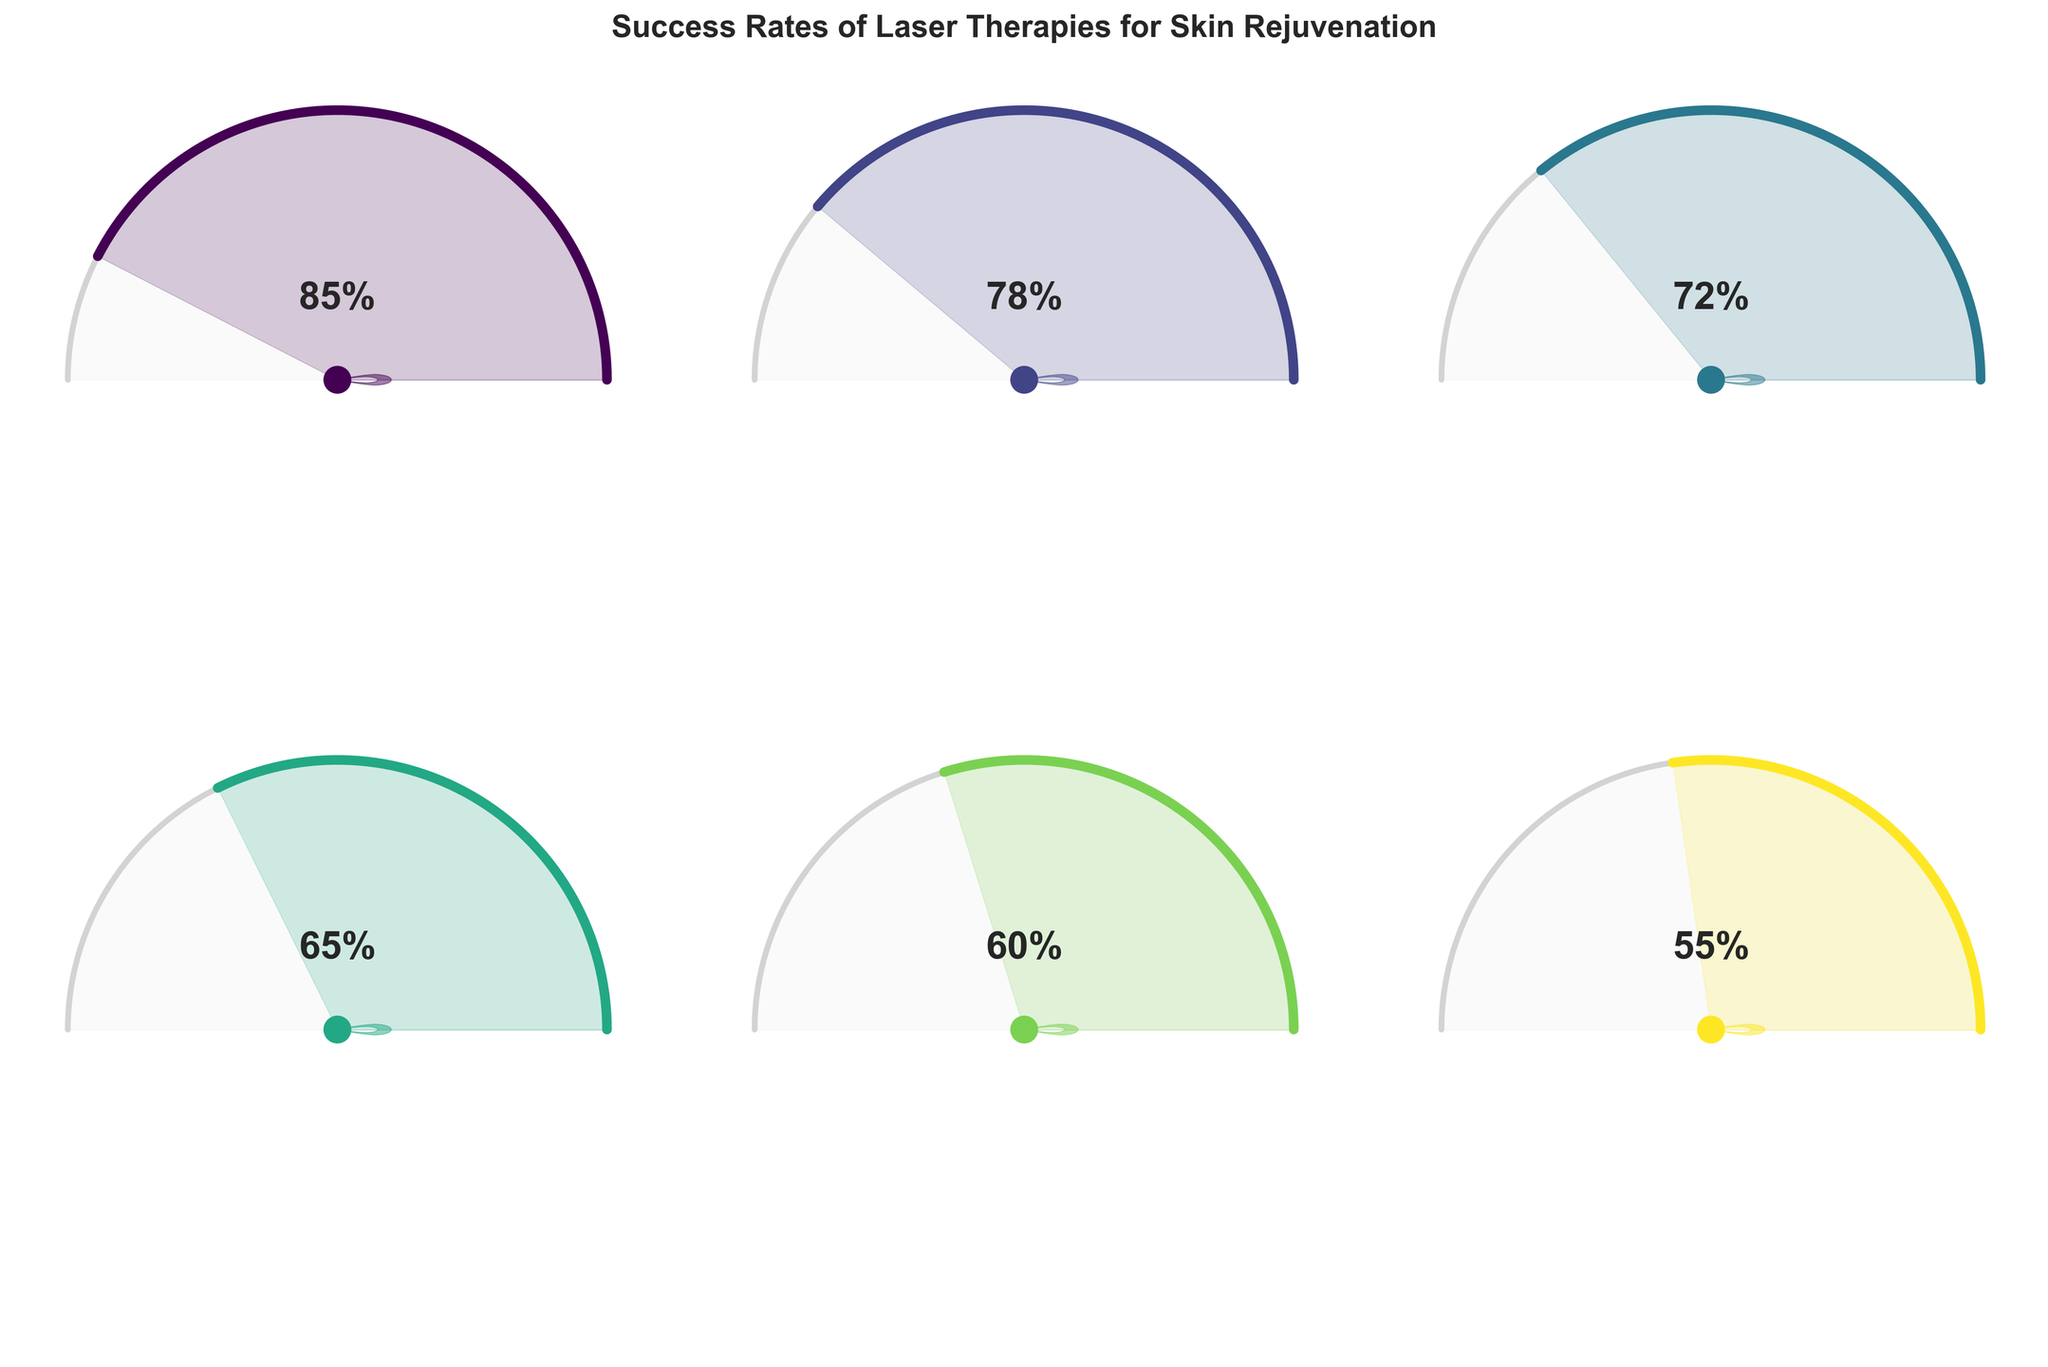What's the title of the figure? The title is prominently displayed at the top of the figure. It reads "Success Rates of Laser Therapies for Skin Rejuvenation".
Answer: Success Rates of Laser Therapies for Skin Rejuvenation How many laser therapy treatments are illustrated in the figure? Each therapy corresponds to an individual gauge chart, and there are six subplots (one for each treatment).
Answer: Six Which laser therapy has the highest success rate? By examining each gauge chart, the CO2 Laser Resurfacing shows the highest value with 85%.
Answer: CO2 Laser Resurfacing What is the success rate of Intense Pulsed Light (IPL) therapy? The label underneath the gauge for IPL therapy states that its success rate is 65%.
Answer: 65% What is the median success rate of all the treatments? The success rates are 85, 78, 72, 65, 60, and 55. Ordering them gives 55, 60, 65, 72, 78, 85. The middle values are 65 and 72. The median is the average of these two: (65+72)/2.
Answer: 68.5% Which laser therapy has a lower success rate, Fractional Laser Therapy or Nd:YAG Laser? Fractional Laser Therapy shows a success rate of 78%, whereas Nd:YAG Laser has a success rate of 60%. 60% is lower than 78%.
Answer: Nd:YAG Laser What is the overall range of success rates shown in the figure? The highest success rate is 85% for CO2 Laser Resurfacing and the lowest is 55% for Pulsed Dye Laser. Range = 85% - 55%.
Answer: 30% Which laser therapy has a success rate closest to the average success rate of all therapies? The average success rate is calculated by summing all success rates and dividing by the number of treatments: (85 + 78 + 72 + 65 + 60 + 55) / 6 = 69.167%. The closest to this average is IPL with 65%.
Answer: Intense Pulsed Light (IPL) Compare the success rate of Erbium YAG Laser to Pulsed Dye Laser. What is the difference? Erbium YAG Laser has a success rate of 72%, and Pulsed Dye Laser has 55%. Difference = 72% - 55%.
Answer: 17% 